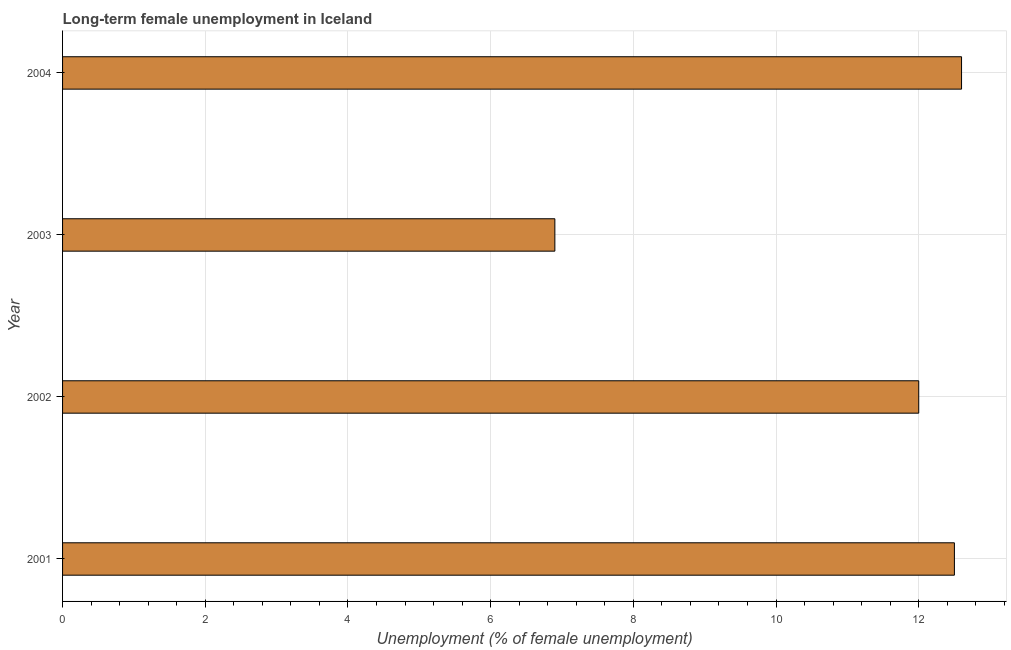Does the graph contain grids?
Your answer should be compact. Yes. What is the title of the graph?
Keep it short and to the point. Long-term female unemployment in Iceland. What is the label or title of the X-axis?
Ensure brevity in your answer.  Unemployment (% of female unemployment). What is the long-term female unemployment in 2003?
Offer a terse response. 6.9. Across all years, what is the maximum long-term female unemployment?
Your answer should be very brief. 12.6. Across all years, what is the minimum long-term female unemployment?
Keep it short and to the point. 6.9. In which year was the long-term female unemployment minimum?
Your answer should be very brief. 2003. What is the sum of the long-term female unemployment?
Provide a short and direct response. 44. What is the median long-term female unemployment?
Keep it short and to the point. 12.25. Do a majority of the years between 2002 and 2003 (inclusive) have long-term female unemployment greater than 8.8 %?
Offer a very short reply. No. What is the ratio of the long-term female unemployment in 2002 to that in 2003?
Offer a very short reply. 1.74. Is the long-term female unemployment in 2001 less than that in 2002?
Your answer should be very brief. No. Is the difference between the long-term female unemployment in 2001 and 2003 greater than the difference between any two years?
Offer a terse response. No. What is the difference between the highest and the lowest long-term female unemployment?
Ensure brevity in your answer.  5.7. In how many years, is the long-term female unemployment greater than the average long-term female unemployment taken over all years?
Provide a succinct answer. 3. What is the Unemployment (% of female unemployment) in 2001?
Provide a short and direct response. 12.5. What is the Unemployment (% of female unemployment) in 2003?
Offer a very short reply. 6.9. What is the Unemployment (% of female unemployment) of 2004?
Offer a terse response. 12.6. What is the difference between the Unemployment (% of female unemployment) in 2001 and 2002?
Offer a terse response. 0.5. What is the difference between the Unemployment (% of female unemployment) in 2001 and 2003?
Ensure brevity in your answer.  5.6. What is the difference between the Unemployment (% of female unemployment) in 2001 and 2004?
Provide a short and direct response. -0.1. What is the difference between the Unemployment (% of female unemployment) in 2002 and 2004?
Ensure brevity in your answer.  -0.6. What is the ratio of the Unemployment (% of female unemployment) in 2001 to that in 2002?
Your answer should be compact. 1.04. What is the ratio of the Unemployment (% of female unemployment) in 2001 to that in 2003?
Keep it short and to the point. 1.81. What is the ratio of the Unemployment (% of female unemployment) in 2001 to that in 2004?
Offer a very short reply. 0.99. What is the ratio of the Unemployment (% of female unemployment) in 2002 to that in 2003?
Provide a short and direct response. 1.74. What is the ratio of the Unemployment (% of female unemployment) in 2003 to that in 2004?
Provide a succinct answer. 0.55. 